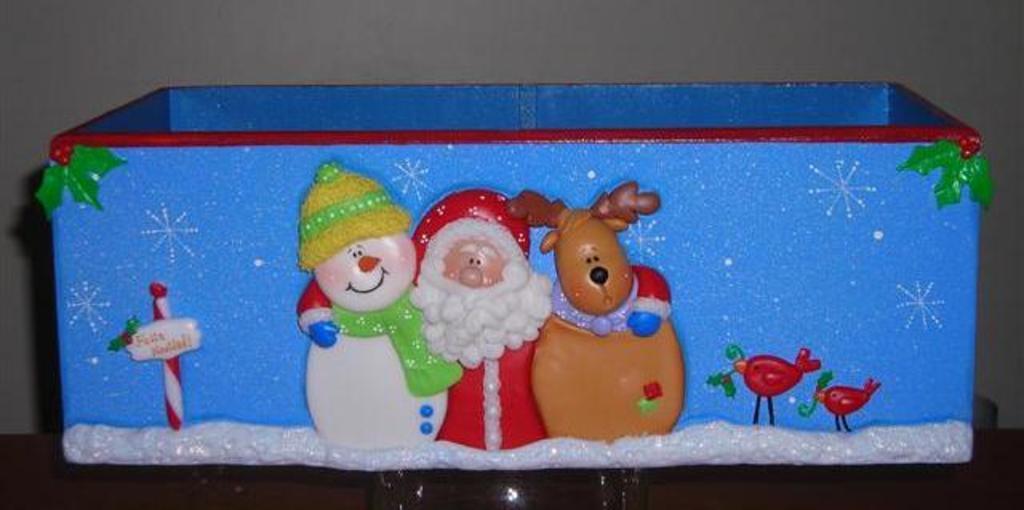Describe this image in one or two sentences. We can see toys on this blue box. Background there is a wall. 